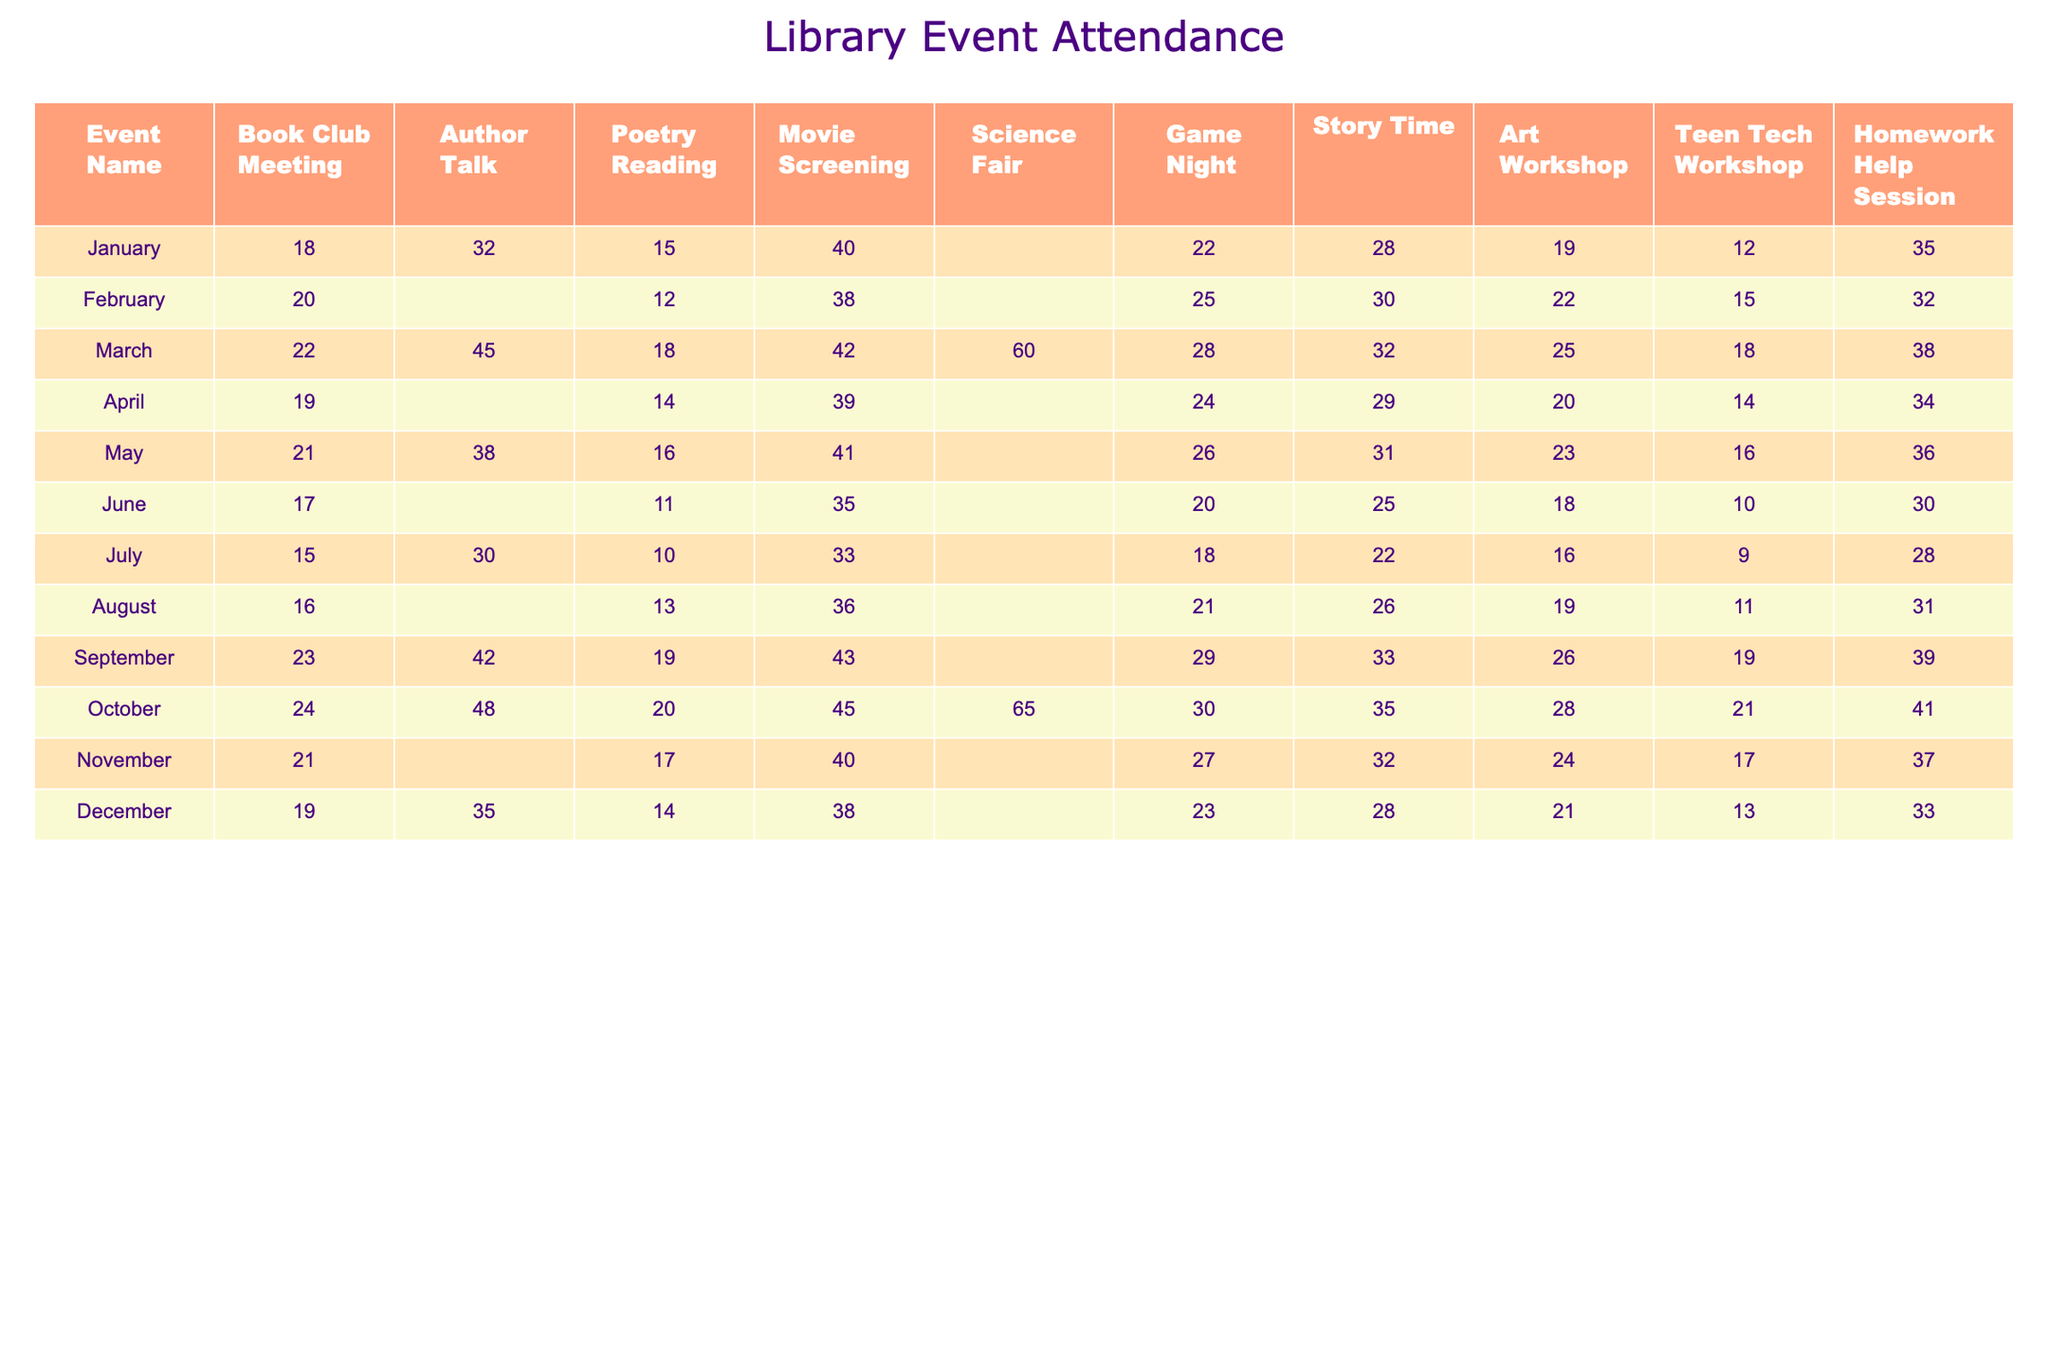What was the attendance for the Author Talk in March? The table shows the attendance for the Author Talk in March is 45.
Answer: 45 Which event had the highest attendance in October? In October, the Science Fair had the highest attendance with 65 participants.
Answer: 65 What is the average attendance for the Game Night events throughout the year? Adding the Game Night attendances: 22 + 25 + 28 + 24 + 26 + 18 + 21 + 30 + 27 + 23 =  24.6 (total 10 events), and dividing by 10 gives an average of 24.6.
Answer: 24.6 Did the Poetry Reading event ever have an attendance of 30 or more? By checking the table, the maximum attendance for the Poetry Reading was 20 in October, so it never reached 30.
Answer: No In which month did the most people attend the Movie Screening? The Movie Screening had the highest attendance in October with 45 participants.
Answer: October What is the total attendance for the Author Talk across all months? Summing the attendance for Author Talks: 32 + 0 + 45 + 0 + 38 + 0 + 30 + 0 + 42 + 48 + 0 + 35 =  316.
Answer: 316 Was the attendance for Homework Help Session consistently above 30 throughout the year? The attendance was 35, 32, 38, 34, 36, 30, 28, 31, 39, 41, 37, and 33; it dropped below 30 only in June and July.
Answer: No Which event had the least attendance in June? In June, the event with the least attendance was the Poetry Reading, with 11 participants.
Answer: Poetry Reading What was the difference in attendance between the highest and lowest attended event in September? In September, the highest attendance was 43 for the Movie Screening and the lowest was 19 for the Poetry Reading; the difference is 43 - 19 = 24.
Answer: 24 How often did the Art Workshop exceed an attendance of 25? The Art Workshop exceeded 25 in March (28), September (26), and October (28), making it 3 times.
Answer: 3 times How many events had an attendance of 20 or fewer in the entire year? Looking through the table, the events with 20 or fewer attendees are 15 (Poetry Reading in January), 12 (Poetry Reading in February), 18 (Poetry Reading in July), 16 (Art Workshop in July), and 10 (Teen Tech Workshop in July), totaling 5 events.
Answer: 5 events 